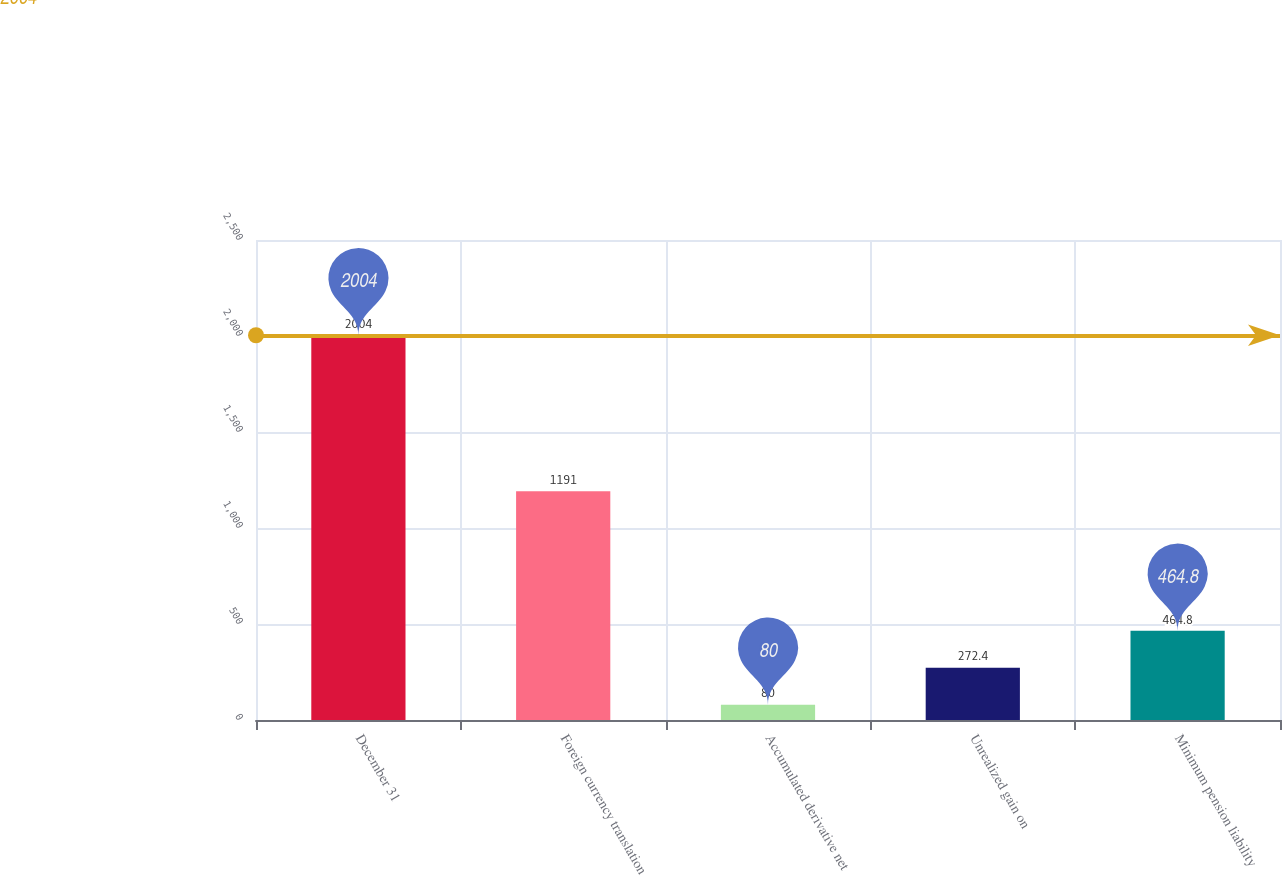<chart> <loc_0><loc_0><loc_500><loc_500><bar_chart><fcel>December 31<fcel>Foreign currency translation<fcel>Accumulated derivative net<fcel>Unrealized gain on<fcel>Minimum pension liability<nl><fcel>2004<fcel>1191<fcel>80<fcel>272.4<fcel>464.8<nl></chart> 